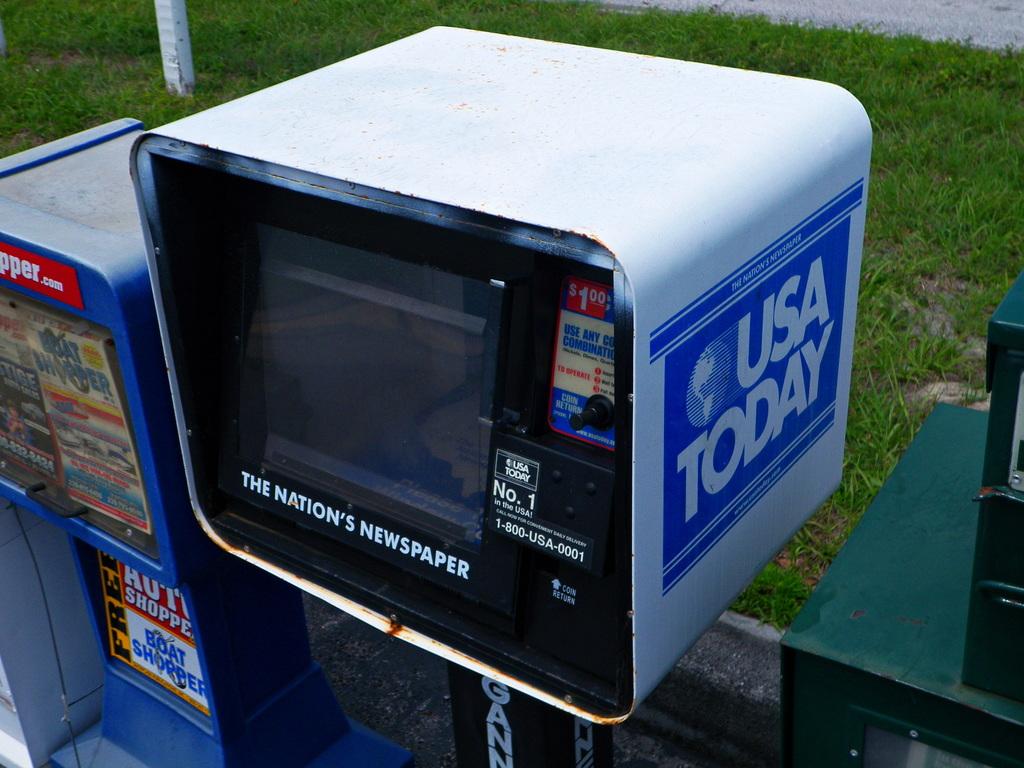What newspaper brand is being sold?
Provide a short and direct response. Usa today. What newspaper can you buy here?
Your answer should be very brief. Usa today. 